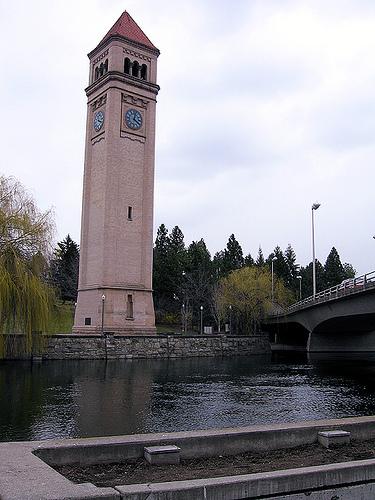Does this water look deep?
Be succinct. Yes. Can you swim here?
Short answer required. No. Is the clock tower digital?
Give a very brief answer. No. 